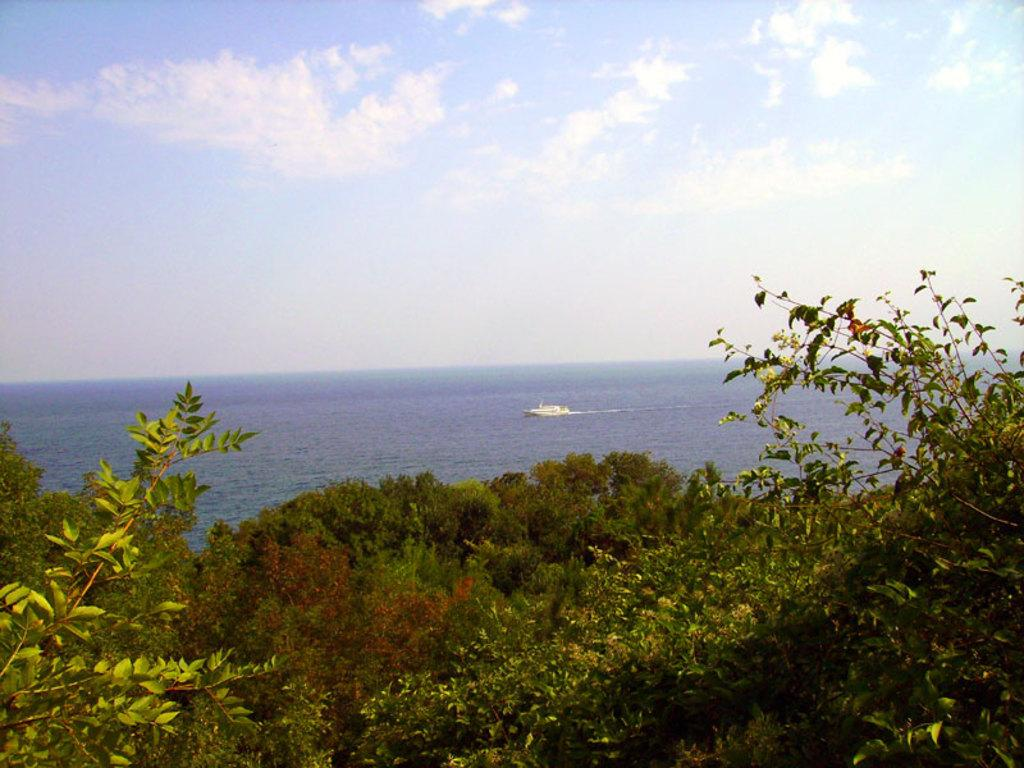What type of vegetation is at the bottom of the image? There are trees at the bottom of the image. What can be seen in the background of the image? There is a boat on the water and clouds in the sky in the background of the image. What type of prose is being recited by the zebra in the image? There is no zebra present in the image, and therefore no prose being recited. How does the boat move in the image? The boat does not move in the image; it is stationary on the water. 